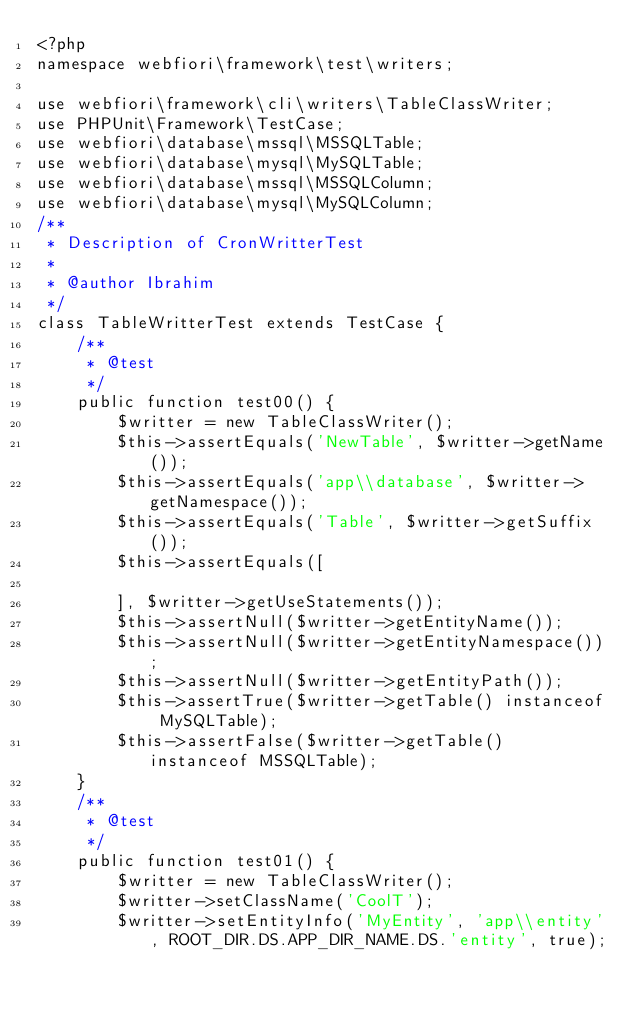<code> <loc_0><loc_0><loc_500><loc_500><_PHP_><?php
namespace webfiori\framework\test\writers;

use webfiori\framework\cli\writers\TableClassWriter;
use PHPUnit\Framework\TestCase;
use webfiori\database\mssql\MSSQLTable;
use webfiori\database\mysql\MySQLTable;
use webfiori\database\mssql\MSSQLColumn;
use webfiori\database\mysql\MySQLColumn;
/**
 * Description of CronWritterTest
 *
 * @author Ibrahim
 */
class TableWritterTest extends TestCase {
    /**
     * @test
     */
    public function test00() {
        $writter = new TableClassWriter();
        $this->assertEquals('NewTable', $writter->getName());
        $this->assertEquals('app\\database', $writter->getNamespace());
        $this->assertEquals('Table', $writter->getSuffix());
        $this->assertEquals([
            
        ], $writter->getUseStatements());
        $this->assertNull($writter->getEntityName());
        $this->assertNull($writter->getEntityNamespace());
        $this->assertNull($writter->getEntityPath());
        $this->assertTrue($writter->getTable() instanceof MySQLTable);
        $this->assertFalse($writter->getTable() instanceof MSSQLTable);
    }
    /**
     * @test
     */
    public function test01() {
        $writter = new TableClassWriter();
        $writter->setClassName('CoolT');
        $writter->setEntityInfo('MyEntity', 'app\\entity', ROOT_DIR.DS.APP_DIR_NAME.DS.'entity', true);</code> 